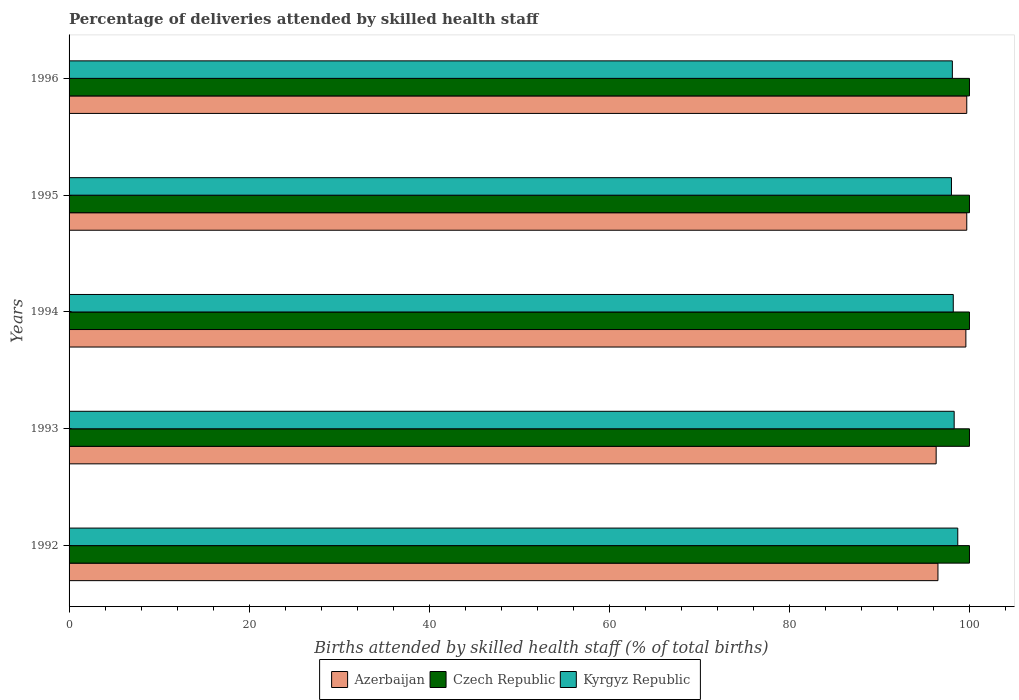How many different coloured bars are there?
Provide a short and direct response. 3. Are the number of bars on each tick of the Y-axis equal?
Provide a short and direct response. Yes. How many bars are there on the 1st tick from the top?
Provide a succinct answer. 3. What is the label of the 5th group of bars from the top?
Make the answer very short. 1992. In which year was the percentage of births attended by skilled health staff in Kyrgyz Republic maximum?
Provide a short and direct response. 1992. What is the total percentage of births attended by skilled health staff in Azerbaijan in the graph?
Provide a short and direct response. 491.8. What is the difference between the percentage of births attended by skilled health staff in Azerbaijan in 1993 and that in 1995?
Offer a terse response. -3.4. What is the difference between the percentage of births attended by skilled health staff in Azerbaijan in 1994 and the percentage of births attended by skilled health staff in Czech Republic in 1995?
Offer a very short reply. -0.4. What is the average percentage of births attended by skilled health staff in Czech Republic per year?
Provide a short and direct response. 100. In the year 1995, what is the difference between the percentage of births attended by skilled health staff in Czech Republic and percentage of births attended by skilled health staff in Azerbaijan?
Make the answer very short. 0.3. In how many years, is the percentage of births attended by skilled health staff in Czech Republic greater than 16 %?
Provide a succinct answer. 5. What is the ratio of the percentage of births attended by skilled health staff in Czech Republic in 1992 to that in 1993?
Provide a short and direct response. 1. Is the percentage of births attended by skilled health staff in Czech Republic in 1994 less than that in 1995?
Your answer should be very brief. No. Is the difference between the percentage of births attended by skilled health staff in Czech Republic in 1994 and 1995 greater than the difference between the percentage of births attended by skilled health staff in Azerbaijan in 1994 and 1995?
Provide a short and direct response. Yes. What is the difference between the highest and the second highest percentage of births attended by skilled health staff in Azerbaijan?
Your answer should be very brief. 0. What is the difference between the highest and the lowest percentage of births attended by skilled health staff in Kyrgyz Republic?
Your response must be concise. 0.7. What does the 3rd bar from the top in 1996 represents?
Provide a short and direct response. Azerbaijan. What does the 2nd bar from the bottom in 1996 represents?
Make the answer very short. Czech Republic. Are the values on the major ticks of X-axis written in scientific E-notation?
Offer a terse response. No. Does the graph contain any zero values?
Ensure brevity in your answer.  No. What is the title of the graph?
Offer a very short reply. Percentage of deliveries attended by skilled health staff. Does "Ireland" appear as one of the legend labels in the graph?
Provide a short and direct response. No. What is the label or title of the X-axis?
Ensure brevity in your answer.  Births attended by skilled health staff (% of total births). What is the Births attended by skilled health staff (% of total births) in Azerbaijan in 1992?
Give a very brief answer. 96.5. What is the Births attended by skilled health staff (% of total births) in Czech Republic in 1992?
Keep it short and to the point. 100. What is the Births attended by skilled health staff (% of total births) in Kyrgyz Republic in 1992?
Offer a terse response. 98.7. What is the Births attended by skilled health staff (% of total births) of Azerbaijan in 1993?
Your answer should be compact. 96.3. What is the Births attended by skilled health staff (% of total births) in Kyrgyz Republic in 1993?
Your response must be concise. 98.3. What is the Births attended by skilled health staff (% of total births) in Azerbaijan in 1994?
Offer a terse response. 99.6. What is the Births attended by skilled health staff (% of total births) in Czech Republic in 1994?
Give a very brief answer. 100. What is the Births attended by skilled health staff (% of total births) of Kyrgyz Republic in 1994?
Offer a terse response. 98.2. What is the Births attended by skilled health staff (% of total births) of Azerbaijan in 1995?
Your response must be concise. 99.7. What is the Births attended by skilled health staff (% of total births) in Czech Republic in 1995?
Your answer should be compact. 100. What is the Births attended by skilled health staff (% of total births) in Kyrgyz Republic in 1995?
Provide a succinct answer. 98. What is the Births attended by skilled health staff (% of total births) in Azerbaijan in 1996?
Offer a terse response. 99.7. What is the Births attended by skilled health staff (% of total births) in Czech Republic in 1996?
Provide a succinct answer. 100. What is the Births attended by skilled health staff (% of total births) of Kyrgyz Republic in 1996?
Your response must be concise. 98.1. Across all years, what is the maximum Births attended by skilled health staff (% of total births) in Azerbaijan?
Give a very brief answer. 99.7. Across all years, what is the maximum Births attended by skilled health staff (% of total births) of Czech Republic?
Your response must be concise. 100. Across all years, what is the maximum Births attended by skilled health staff (% of total births) in Kyrgyz Republic?
Provide a succinct answer. 98.7. Across all years, what is the minimum Births attended by skilled health staff (% of total births) of Azerbaijan?
Your answer should be compact. 96.3. What is the total Births attended by skilled health staff (% of total births) of Azerbaijan in the graph?
Provide a succinct answer. 491.8. What is the total Births attended by skilled health staff (% of total births) in Kyrgyz Republic in the graph?
Keep it short and to the point. 491.3. What is the difference between the Births attended by skilled health staff (% of total births) of Czech Republic in 1992 and that in 1994?
Your answer should be very brief. 0. What is the difference between the Births attended by skilled health staff (% of total births) in Azerbaijan in 1992 and that in 1995?
Give a very brief answer. -3.2. What is the difference between the Births attended by skilled health staff (% of total births) in Czech Republic in 1992 and that in 1996?
Offer a very short reply. 0. What is the difference between the Births attended by skilled health staff (% of total births) in Azerbaijan in 1993 and that in 1995?
Ensure brevity in your answer.  -3.4. What is the difference between the Births attended by skilled health staff (% of total births) in Kyrgyz Republic in 1993 and that in 1995?
Provide a short and direct response. 0.3. What is the difference between the Births attended by skilled health staff (% of total births) of Azerbaijan in 1993 and that in 1996?
Provide a succinct answer. -3.4. What is the difference between the Births attended by skilled health staff (% of total births) of Azerbaijan in 1994 and that in 1995?
Your answer should be very brief. -0.1. What is the difference between the Births attended by skilled health staff (% of total births) in Kyrgyz Republic in 1994 and that in 1996?
Provide a short and direct response. 0.1. What is the difference between the Births attended by skilled health staff (% of total births) in Azerbaijan in 1995 and that in 1996?
Your answer should be compact. 0. What is the difference between the Births attended by skilled health staff (% of total births) of Czech Republic in 1995 and that in 1996?
Keep it short and to the point. 0. What is the difference between the Births attended by skilled health staff (% of total births) in Kyrgyz Republic in 1995 and that in 1996?
Offer a very short reply. -0.1. What is the difference between the Births attended by skilled health staff (% of total births) of Azerbaijan in 1992 and the Births attended by skilled health staff (% of total births) of Kyrgyz Republic in 1993?
Your answer should be compact. -1.8. What is the difference between the Births attended by skilled health staff (% of total births) in Czech Republic in 1992 and the Births attended by skilled health staff (% of total births) in Kyrgyz Republic in 1994?
Give a very brief answer. 1.8. What is the difference between the Births attended by skilled health staff (% of total births) of Azerbaijan in 1992 and the Births attended by skilled health staff (% of total births) of Czech Republic in 1995?
Make the answer very short. -3.5. What is the difference between the Births attended by skilled health staff (% of total births) in Azerbaijan in 1992 and the Births attended by skilled health staff (% of total births) in Kyrgyz Republic in 1995?
Give a very brief answer. -1.5. What is the difference between the Births attended by skilled health staff (% of total births) of Czech Republic in 1992 and the Births attended by skilled health staff (% of total births) of Kyrgyz Republic in 1995?
Ensure brevity in your answer.  2. What is the difference between the Births attended by skilled health staff (% of total births) of Czech Republic in 1992 and the Births attended by skilled health staff (% of total births) of Kyrgyz Republic in 1996?
Keep it short and to the point. 1.9. What is the difference between the Births attended by skilled health staff (% of total births) in Azerbaijan in 1993 and the Births attended by skilled health staff (% of total births) in Czech Republic in 1994?
Offer a very short reply. -3.7. What is the difference between the Births attended by skilled health staff (% of total births) of Czech Republic in 1993 and the Births attended by skilled health staff (% of total births) of Kyrgyz Republic in 1994?
Give a very brief answer. 1.8. What is the difference between the Births attended by skilled health staff (% of total births) of Azerbaijan in 1993 and the Births attended by skilled health staff (% of total births) of Czech Republic in 1995?
Keep it short and to the point. -3.7. What is the difference between the Births attended by skilled health staff (% of total births) in Azerbaijan in 1993 and the Births attended by skilled health staff (% of total births) in Kyrgyz Republic in 1995?
Your answer should be very brief. -1.7. What is the difference between the Births attended by skilled health staff (% of total births) of Czech Republic in 1993 and the Births attended by skilled health staff (% of total births) of Kyrgyz Republic in 1995?
Provide a succinct answer. 2. What is the difference between the Births attended by skilled health staff (% of total births) in Azerbaijan in 1994 and the Births attended by skilled health staff (% of total births) in Czech Republic in 1995?
Ensure brevity in your answer.  -0.4. What is the difference between the Births attended by skilled health staff (% of total births) in Azerbaijan in 1994 and the Births attended by skilled health staff (% of total births) in Kyrgyz Republic in 1995?
Give a very brief answer. 1.6. What is the difference between the Births attended by skilled health staff (% of total births) in Czech Republic in 1994 and the Births attended by skilled health staff (% of total births) in Kyrgyz Republic in 1995?
Your answer should be very brief. 2. What is the difference between the Births attended by skilled health staff (% of total births) in Azerbaijan in 1994 and the Births attended by skilled health staff (% of total births) in Kyrgyz Republic in 1996?
Your response must be concise. 1.5. What is the difference between the Births attended by skilled health staff (% of total births) of Czech Republic in 1994 and the Births attended by skilled health staff (% of total births) of Kyrgyz Republic in 1996?
Your response must be concise. 1.9. What is the average Births attended by skilled health staff (% of total births) in Azerbaijan per year?
Your answer should be compact. 98.36. What is the average Births attended by skilled health staff (% of total births) in Czech Republic per year?
Offer a terse response. 100. What is the average Births attended by skilled health staff (% of total births) of Kyrgyz Republic per year?
Give a very brief answer. 98.26. In the year 1992, what is the difference between the Births attended by skilled health staff (% of total births) in Azerbaijan and Births attended by skilled health staff (% of total births) in Czech Republic?
Offer a terse response. -3.5. In the year 1994, what is the difference between the Births attended by skilled health staff (% of total births) of Azerbaijan and Births attended by skilled health staff (% of total births) of Czech Republic?
Offer a terse response. -0.4. In the year 1994, what is the difference between the Births attended by skilled health staff (% of total births) in Czech Republic and Births attended by skilled health staff (% of total births) in Kyrgyz Republic?
Keep it short and to the point. 1.8. In the year 1996, what is the difference between the Births attended by skilled health staff (% of total births) of Azerbaijan and Births attended by skilled health staff (% of total births) of Kyrgyz Republic?
Your answer should be compact. 1.6. What is the ratio of the Births attended by skilled health staff (% of total births) in Azerbaijan in 1992 to that in 1993?
Keep it short and to the point. 1. What is the ratio of the Births attended by skilled health staff (% of total births) in Azerbaijan in 1992 to that in 1994?
Ensure brevity in your answer.  0.97. What is the ratio of the Births attended by skilled health staff (% of total births) in Kyrgyz Republic in 1992 to that in 1994?
Your answer should be very brief. 1.01. What is the ratio of the Births attended by skilled health staff (% of total births) in Azerbaijan in 1992 to that in 1995?
Your answer should be very brief. 0.97. What is the ratio of the Births attended by skilled health staff (% of total births) of Kyrgyz Republic in 1992 to that in 1995?
Your response must be concise. 1.01. What is the ratio of the Births attended by skilled health staff (% of total births) of Azerbaijan in 1992 to that in 1996?
Provide a short and direct response. 0.97. What is the ratio of the Births attended by skilled health staff (% of total births) of Czech Republic in 1992 to that in 1996?
Offer a terse response. 1. What is the ratio of the Births attended by skilled health staff (% of total births) in Azerbaijan in 1993 to that in 1994?
Offer a terse response. 0.97. What is the ratio of the Births attended by skilled health staff (% of total births) in Azerbaijan in 1993 to that in 1995?
Ensure brevity in your answer.  0.97. What is the ratio of the Births attended by skilled health staff (% of total births) of Czech Republic in 1993 to that in 1995?
Offer a terse response. 1. What is the ratio of the Births attended by skilled health staff (% of total births) in Kyrgyz Republic in 1993 to that in 1995?
Your response must be concise. 1. What is the ratio of the Births attended by skilled health staff (% of total births) of Azerbaijan in 1993 to that in 1996?
Make the answer very short. 0.97. What is the ratio of the Births attended by skilled health staff (% of total births) of Czech Republic in 1993 to that in 1996?
Provide a succinct answer. 1. What is the ratio of the Births attended by skilled health staff (% of total births) of Azerbaijan in 1994 to that in 1995?
Your response must be concise. 1. What is the ratio of the Births attended by skilled health staff (% of total births) of Kyrgyz Republic in 1994 to that in 1995?
Provide a succinct answer. 1. What is the ratio of the Births attended by skilled health staff (% of total births) in Azerbaijan in 1995 to that in 1996?
Provide a short and direct response. 1. What is the ratio of the Births attended by skilled health staff (% of total births) of Czech Republic in 1995 to that in 1996?
Your answer should be very brief. 1. What is the difference between the highest and the second highest Births attended by skilled health staff (% of total births) of Czech Republic?
Provide a succinct answer. 0. 